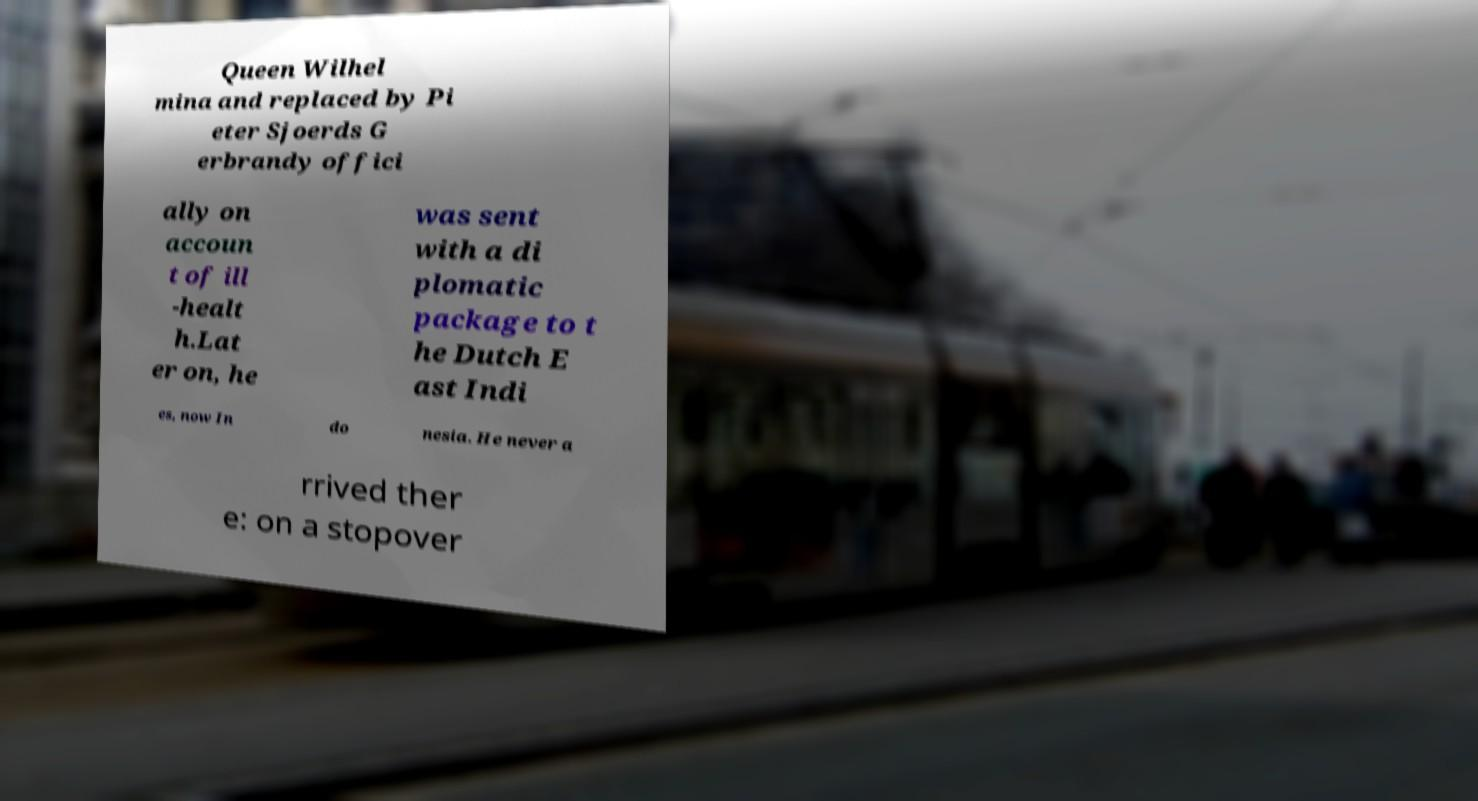Could you assist in decoding the text presented in this image and type it out clearly? Queen Wilhel mina and replaced by Pi eter Sjoerds G erbrandy offici ally on accoun t of ill -healt h.Lat er on, he was sent with a di plomatic package to t he Dutch E ast Indi es, now In do nesia. He never a rrived ther e: on a stopover 